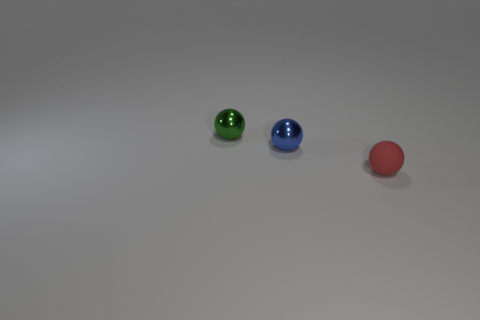Add 3 big red rubber cylinders. How many objects exist? 6 Subtract all small metal things. Subtract all large purple blocks. How many objects are left? 1 Add 1 red rubber things. How many red rubber things are left? 2 Add 1 green balls. How many green balls exist? 2 Subtract 0 green cylinders. How many objects are left? 3 